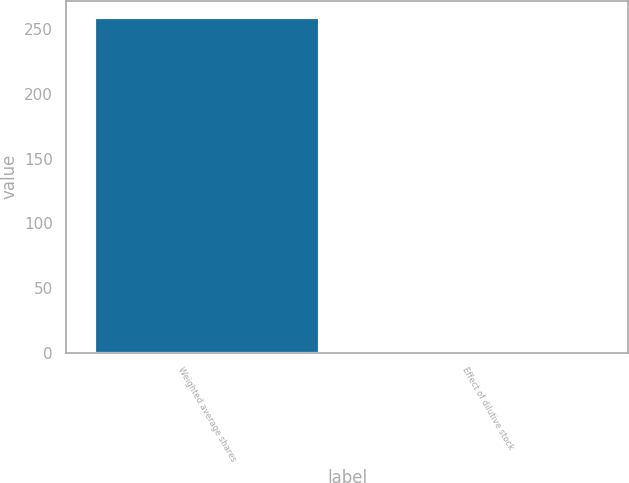<chart> <loc_0><loc_0><loc_500><loc_500><bar_chart><fcel>Weighted average shares<fcel>Effect of dilutive stock<nl><fcel>259.05<fcel>2<nl></chart> 